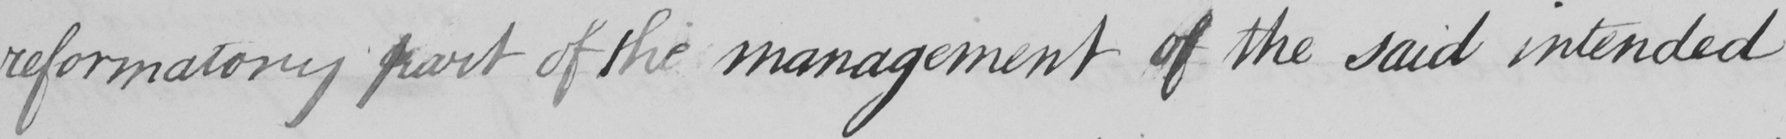What is written in this line of handwriting? reformatory part of the management of the said intended 